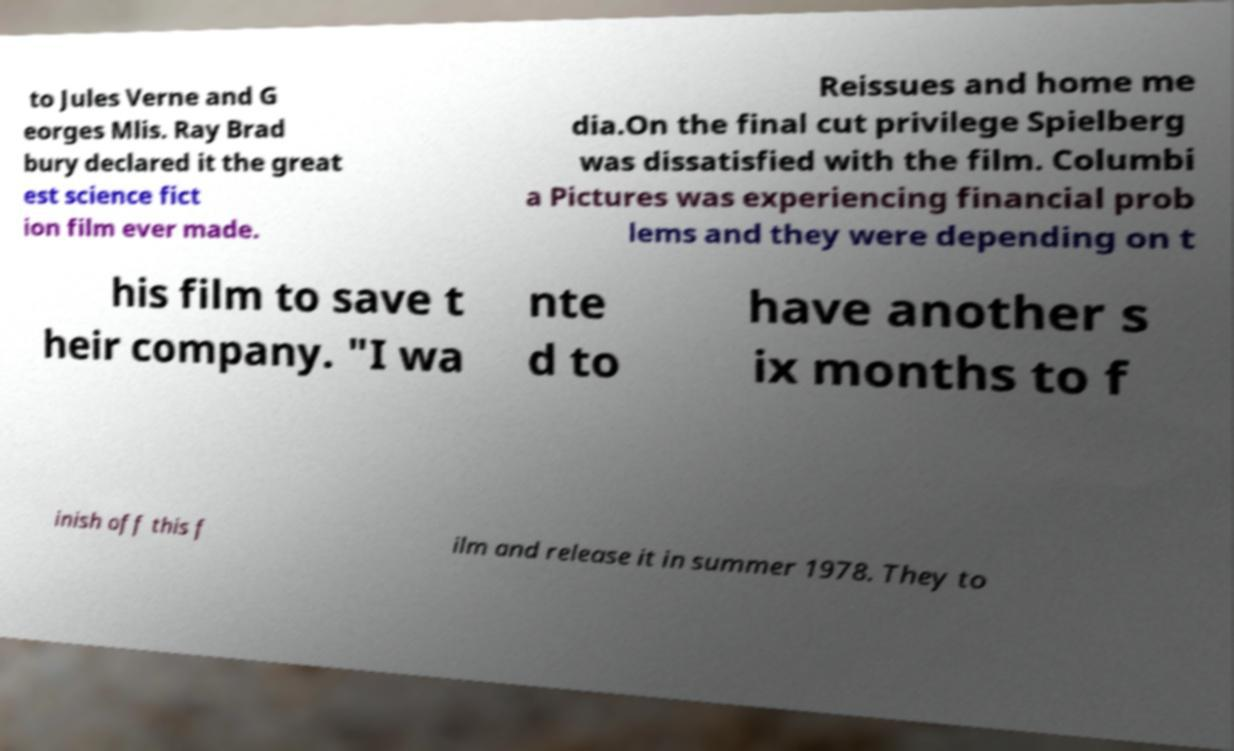Please read and relay the text visible in this image. What does it say? to Jules Verne and G eorges Mlis. Ray Brad bury declared it the great est science fict ion film ever made. Reissues and home me dia.On the final cut privilege Spielberg was dissatisfied with the film. Columbi a Pictures was experiencing financial prob lems and they were depending on t his film to save t heir company. "I wa nte d to have another s ix months to f inish off this f ilm and release it in summer 1978. They to 